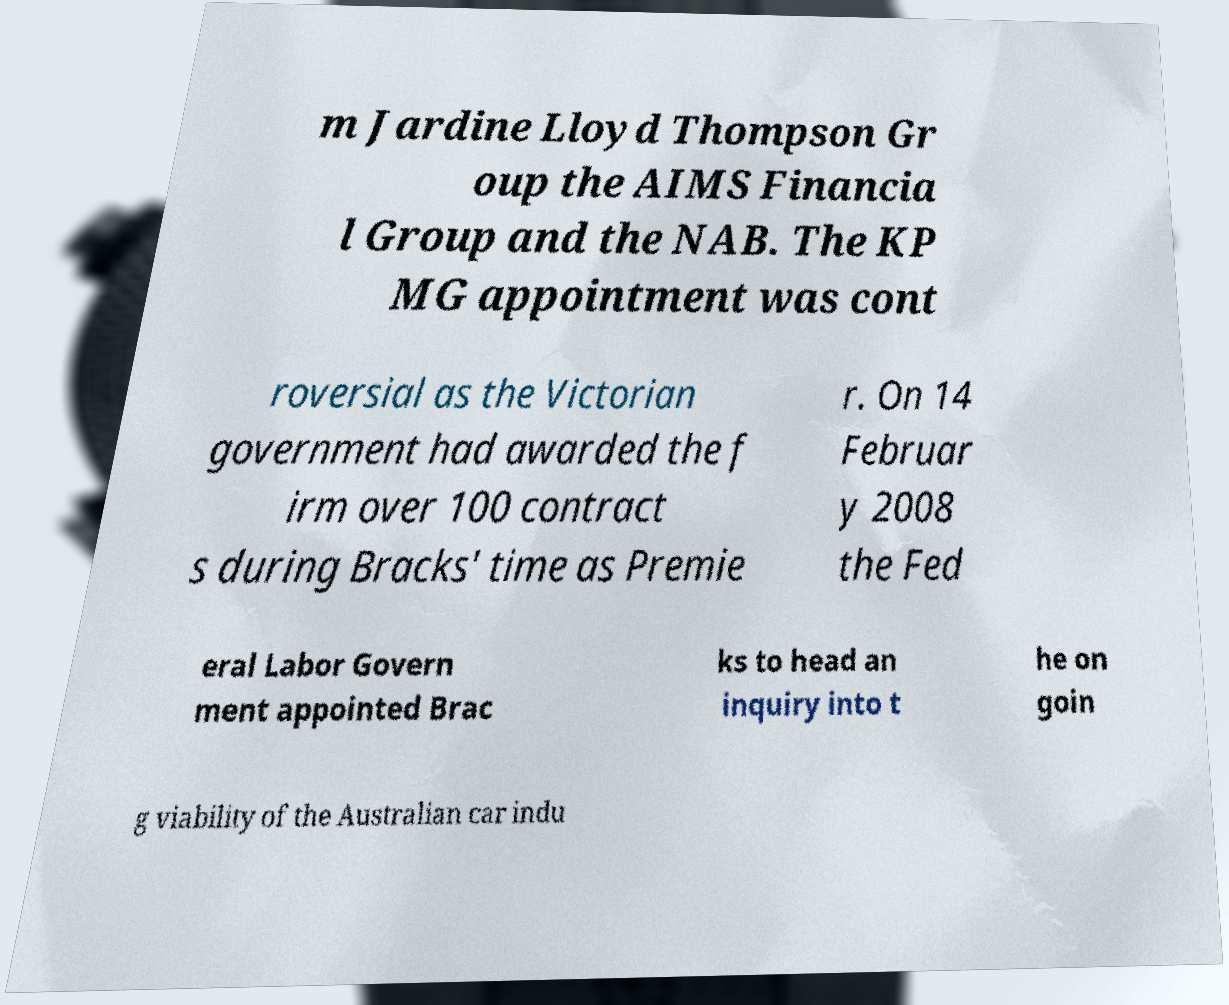Could you assist in decoding the text presented in this image and type it out clearly? m Jardine Lloyd Thompson Gr oup the AIMS Financia l Group and the NAB. The KP MG appointment was cont roversial as the Victorian government had awarded the f irm over 100 contract s during Bracks' time as Premie r. On 14 Februar y 2008 the Fed eral Labor Govern ment appointed Brac ks to head an inquiry into t he on goin g viability of the Australian car indu 